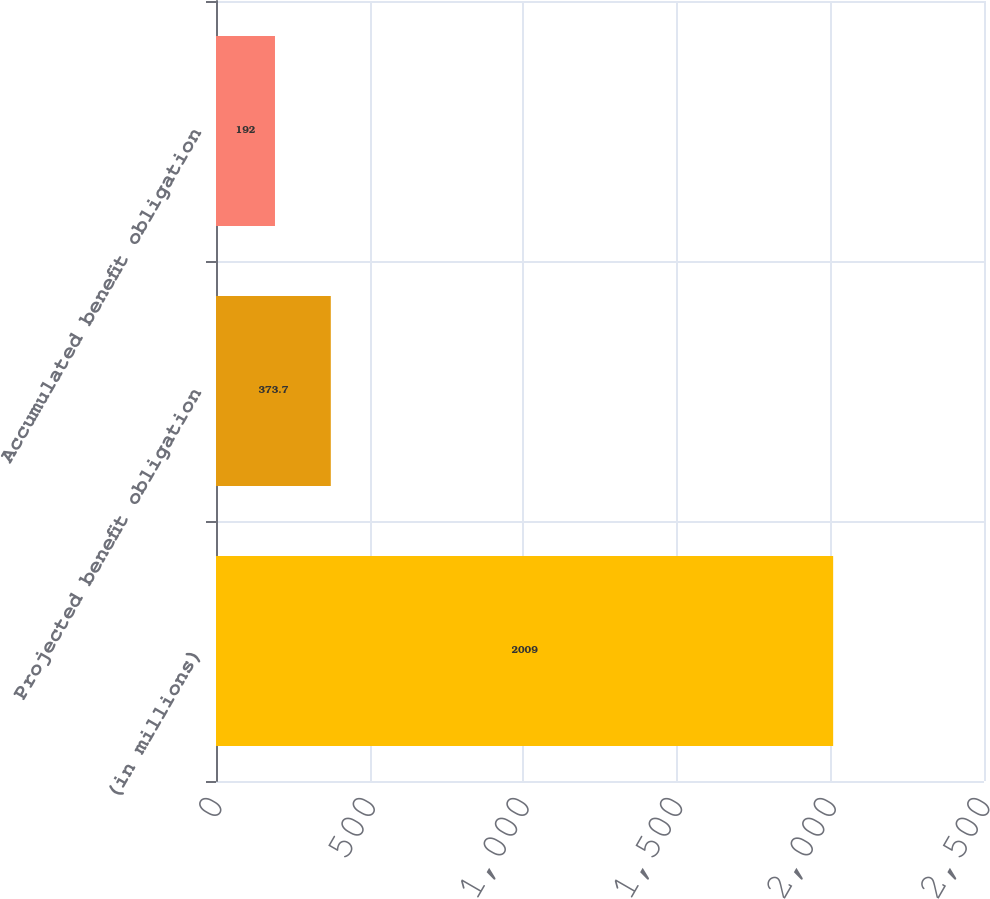Convert chart. <chart><loc_0><loc_0><loc_500><loc_500><bar_chart><fcel>(in millions)<fcel>Projected benefit obligation<fcel>Accumulated benefit obligation<nl><fcel>2009<fcel>373.7<fcel>192<nl></chart> 